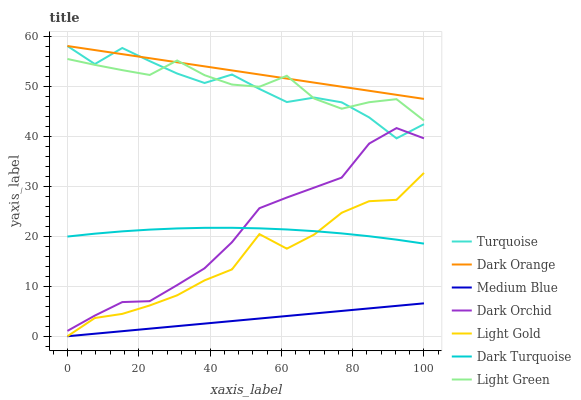Does Medium Blue have the minimum area under the curve?
Answer yes or no. Yes. Does Dark Orange have the maximum area under the curve?
Answer yes or no. Yes. Does Turquoise have the minimum area under the curve?
Answer yes or no. No. Does Turquoise have the maximum area under the curve?
Answer yes or no. No. Is Medium Blue the smoothest?
Answer yes or no. Yes. Is Turquoise the roughest?
Answer yes or no. Yes. Is Dark Turquoise the smoothest?
Answer yes or no. No. Is Dark Turquoise the roughest?
Answer yes or no. No. Does Turquoise have the lowest value?
Answer yes or no. No. Does Turquoise have the highest value?
Answer yes or no. Yes. Does Dark Turquoise have the highest value?
Answer yes or no. No. Is Dark Turquoise less than Turquoise?
Answer yes or no. Yes. Is Turquoise greater than Light Gold?
Answer yes or no. Yes. Does Turquoise intersect Dark Orchid?
Answer yes or no. Yes. Is Turquoise less than Dark Orchid?
Answer yes or no. No. Is Turquoise greater than Dark Orchid?
Answer yes or no. No. Does Dark Turquoise intersect Turquoise?
Answer yes or no. No. 